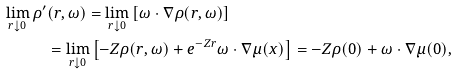<formula> <loc_0><loc_0><loc_500><loc_500>\lim _ { r \downarrow 0 } \rho ^ { \prime } & ( r , \omega ) = \lim _ { r \downarrow 0 } \left [ \omega \cdot \nabla \rho ( r , \omega ) \right ] \\ & = \lim _ { r \downarrow 0 } \left [ - Z \rho ( r , \omega ) + e ^ { - Z r } \omega \cdot \nabla \mu ( x ) \right ] = - Z \rho ( 0 ) + \omega \cdot \nabla \mu ( 0 ) ,</formula> 